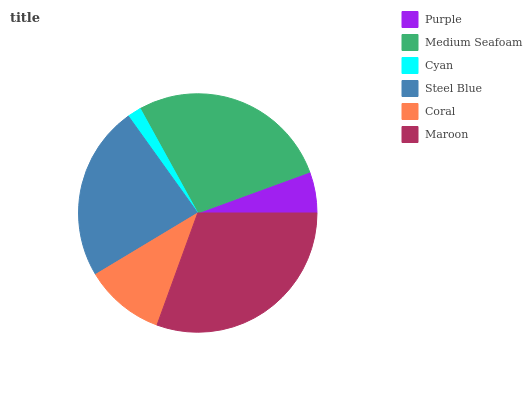Is Cyan the minimum?
Answer yes or no. Yes. Is Maroon the maximum?
Answer yes or no. Yes. Is Medium Seafoam the minimum?
Answer yes or no. No. Is Medium Seafoam the maximum?
Answer yes or no. No. Is Medium Seafoam greater than Purple?
Answer yes or no. Yes. Is Purple less than Medium Seafoam?
Answer yes or no. Yes. Is Purple greater than Medium Seafoam?
Answer yes or no. No. Is Medium Seafoam less than Purple?
Answer yes or no. No. Is Steel Blue the high median?
Answer yes or no. Yes. Is Coral the low median?
Answer yes or no. Yes. Is Maroon the high median?
Answer yes or no. No. Is Cyan the low median?
Answer yes or no. No. 